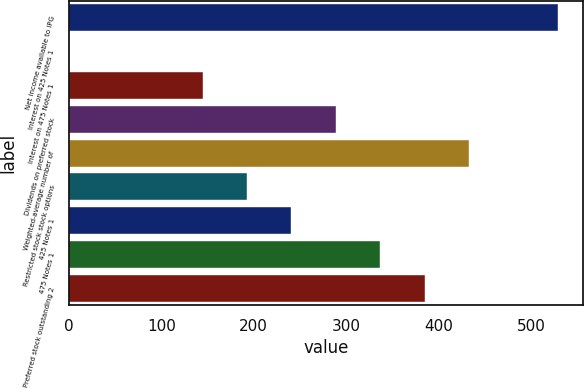Convert chart to OTSL. <chart><loc_0><loc_0><loc_500><loc_500><bar_chart><fcel>Net income available to IPG<fcel>Interest on 425 Notes 1<fcel>Interest on 475 Notes 1<fcel>Dividends on preferred stock<fcel>Weighted-average number of<fcel>Restricted stock stock options<fcel>425 Notes 1<fcel>475 Notes 1<fcel>Preferred stock outstanding 2<nl><fcel>529.51<fcel>0.3<fcel>144.63<fcel>288.96<fcel>433.29<fcel>192.74<fcel>240.85<fcel>337.07<fcel>385.18<nl></chart> 